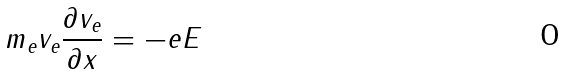<formula> <loc_0><loc_0><loc_500><loc_500>m _ { e } v _ { e } \frac { \partial v _ { e } } { \partial x } = - e E</formula> 